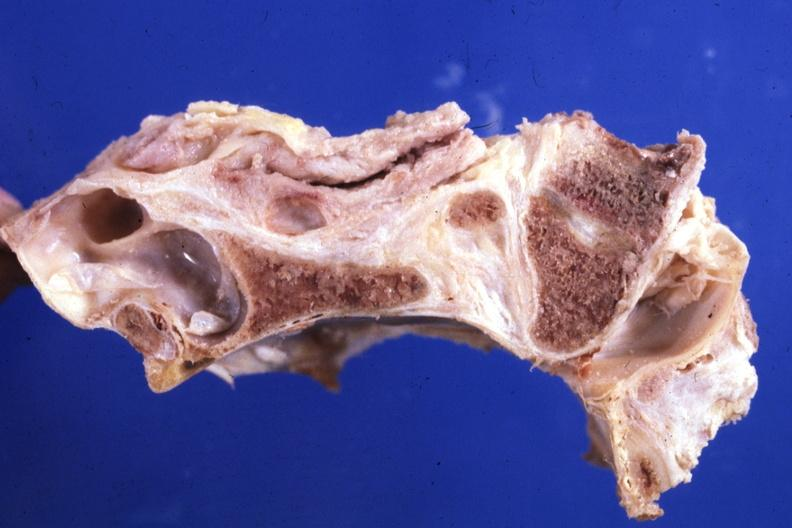s rheumatoid arthritis present?
Answer the question using a single word or phrase. Yes 